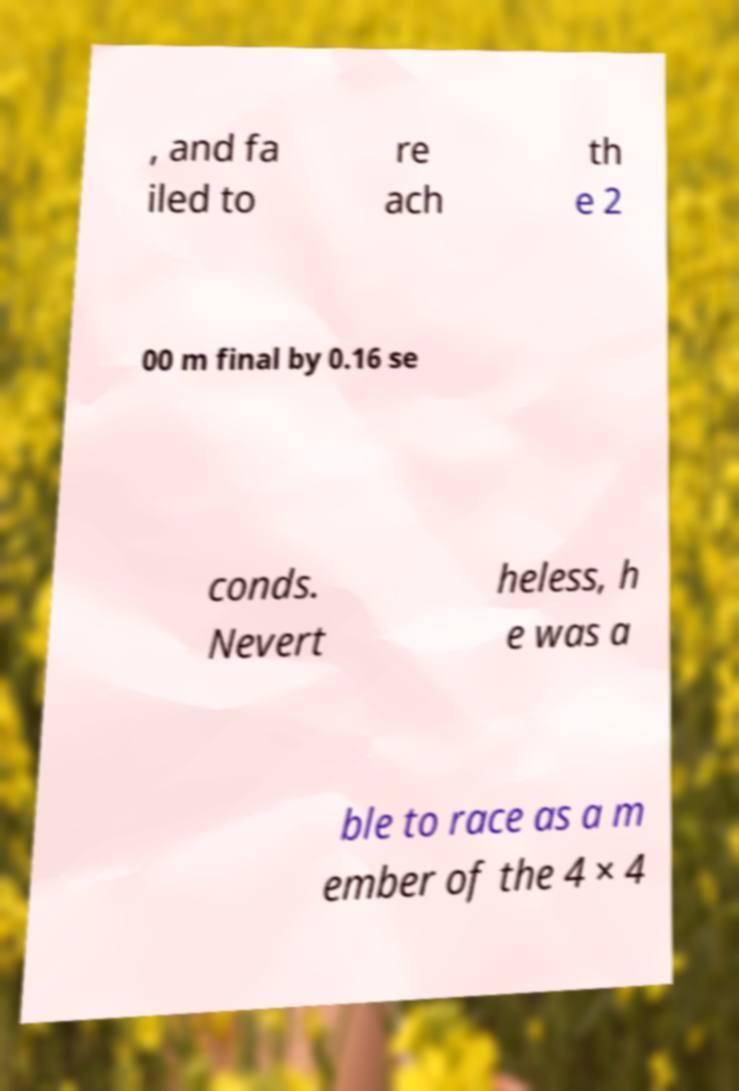I need the written content from this picture converted into text. Can you do that? , and fa iled to re ach th e 2 00 m final by 0.16 se conds. Nevert heless, h e was a ble to race as a m ember of the 4 × 4 